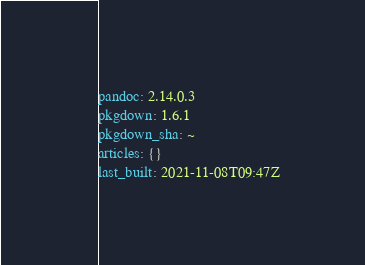<code> <loc_0><loc_0><loc_500><loc_500><_YAML_>pandoc: 2.14.0.3
pkgdown: 1.6.1
pkgdown_sha: ~
articles: {}
last_built: 2021-11-08T09:47Z

</code> 